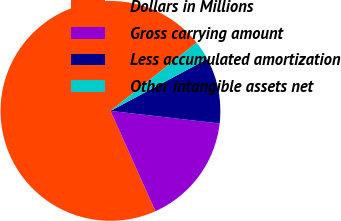Convert chart to OTSL. <chart><loc_0><loc_0><loc_500><loc_500><pie_chart><fcel>Dollars in Millions<fcel>Gross carrying amount<fcel>Less accumulated amortization<fcel>Other intangible assets net<nl><fcel>71.04%<fcel>16.47%<fcel>9.65%<fcel>2.83%<nl></chart> 